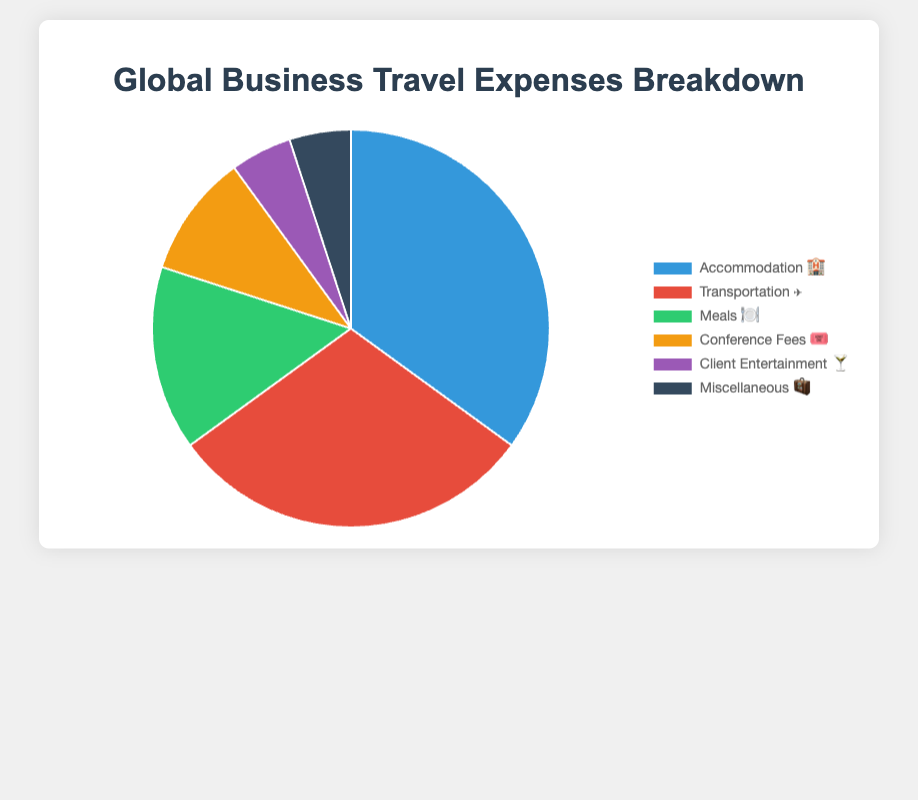What category has the largest expense in global business travel? The largest slice in the pie chart represents "Accommodation 🏨" with 35%, which is the highest percentage among all categories.
Answer: Accommodation 🏨 What is the smallest category of expenses in global business travel? Both "Client Entertainment 🍸" and "Miscellaneous 🧳" categories have the smallest slices, each representing 5% of the total expenses.
Answer: Client Entertainment 🍸 and Miscellaneous 🧳 How much more is spent on Transportation ✈️ compared to Meals 🍽️? Transportation ✈️ accounts for 30% while Meals 🍽️ accounts for 15%. Subtracting these percentages, 30% - 15% = 15%.
Answer: 15% What percentage of global business travel expenses is spent on categories other than Accommodation 🏨 and Transportation ✈️? Accommodation 🏨 is 35% and Transportation ✈️ is 30%. The sum of these two is 65%. The remaining percentage is 100% - 65% = 35%.
Answer: 35% Which two categories together make up 70% of the global business travel expenses? Accommodation 🏨 is 35% and Transportation ✈️ is 30%. Adding these, 35% + 30% = 65%. Adding Meals 🍽️, which is 15%, to either, surpasses 70%. Hence, Accommodation 🏨 and Meals 🍽️ = 50%, Accommodation 🏨 and Conference Fees 🎟️ = 45%, but only Accommodation 🏨 and Transportation ✈️ equal exactly 65%.
Answer: Accommodation 🏨 and Transportation ✈️ What's the combined percentage for Conference Fees 🎟️ and Client Entertainment 🍸? Conference Fees 🎟️ represent 10% and Client Entertainment 🍸 represent 5%. Adding these percentages, 10% + 5% = 15%.
Answer: 15% Is the percentage spent on Meals 🍽️ greater than the combined percentage spent on Client Entertainment 🍸 and Miscellaneous 🧳? Meals 🍽️ account for 15%, Client Entertainment 🍸 is 5%, and Miscellaneous 🧳 is 5%. Summing Client Entertainment 🍸 and Miscellaneous 🧳, 5% + 5% = 10%, which is less than 15%.
Answer: Yes How much more is spent on Meals 🍽️ compared to the sum of Client Entertainment 🍸 and Miscellaneous 🧳? Meals 🍽️ is 15%, Client Entertainment 🍸 is 5%, and Miscellaneous 🧳 is 5%. Summing Client Entertainment 🍸 and Miscellaneous 🧳 is 5% + 5% = 10%. The difference is 15% - 10% = 5%.
Answer: 5% What is the difference in expense percentages between the highest and lowest categories? The highest category is Accommodation 🏨 at 35% and the lowest are Client Entertainment 🍸 and Miscellaneous 🧳 at 5% each. The difference is 35% - 5% = 30%.
Answer: 30% 